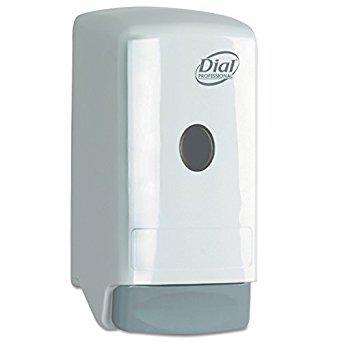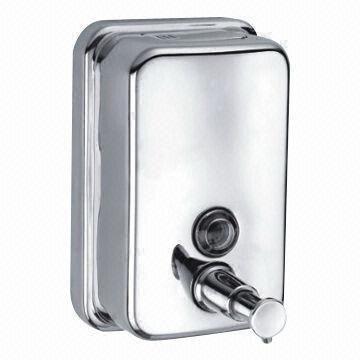The first image is the image on the left, the second image is the image on the right. Considering the images on both sides, is "The two dispensers in the paired images appear to face toward each other." valid? Answer yes or no. No. 